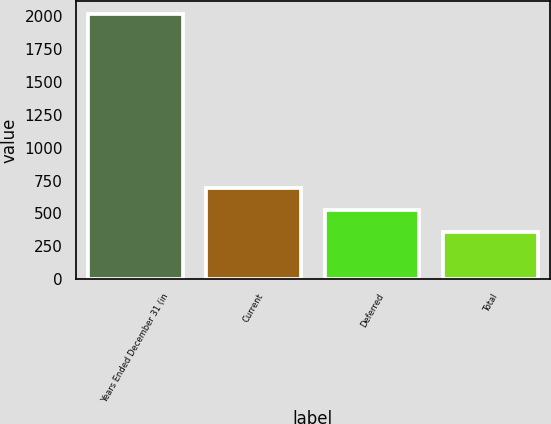<chart> <loc_0><loc_0><loc_500><loc_500><bar_chart><fcel>Years Ended December 31 (in<fcel>Current<fcel>Deferred<fcel>Total<nl><fcel>2013<fcel>690.6<fcel>525.3<fcel>360<nl></chart> 